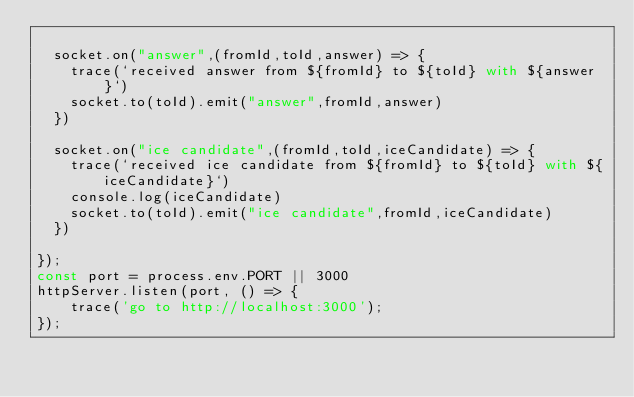<code> <loc_0><loc_0><loc_500><loc_500><_JavaScript_>
  socket.on("answer",(fromId,toId,answer) => {
    trace(`received answer from ${fromId} to ${toId} with ${answer}`)
    socket.to(toId).emit("answer",fromId,answer)
  })

  socket.on("ice candidate",(fromId,toId,iceCandidate) => {
    trace(`received ice candidate from ${fromId} to ${toId} with ${iceCandidate}`)
    console.log(iceCandidate)
    socket.to(toId).emit("ice candidate",fromId,iceCandidate)
  })

});
const port = process.env.PORT || 3000
httpServer.listen(port, () => {
    trace('go to http://localhost:3000');
});
</code> 